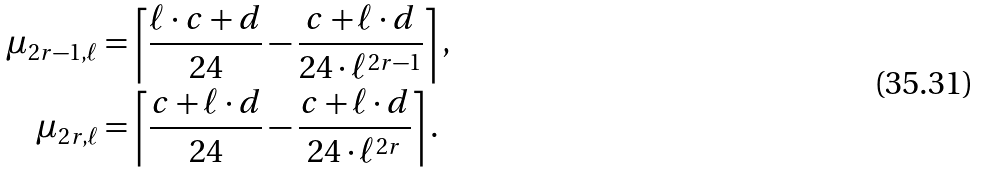Convert formula to latex. <formula><loc_0><loc_0><loc_500><loc_500>\mu _ { 2 r - 1 , \ell } & = \left \lceil \frac { \ell \cdot c + d } { 2 4 } - \frac { c + \ell \cdot d } { 2 4 \cdot \ell ^ { 2 r - 1 } } \right \rceil , \\ \mu _ { 2 r , \ell } & = \left \lceil \frac { c + \ell \cdot d } { 2 4 } - \frac { c + \ell \cdot d } { 2 4 \cdot { \ell } ^ { 2 r } } \right \rceil .</formula> 